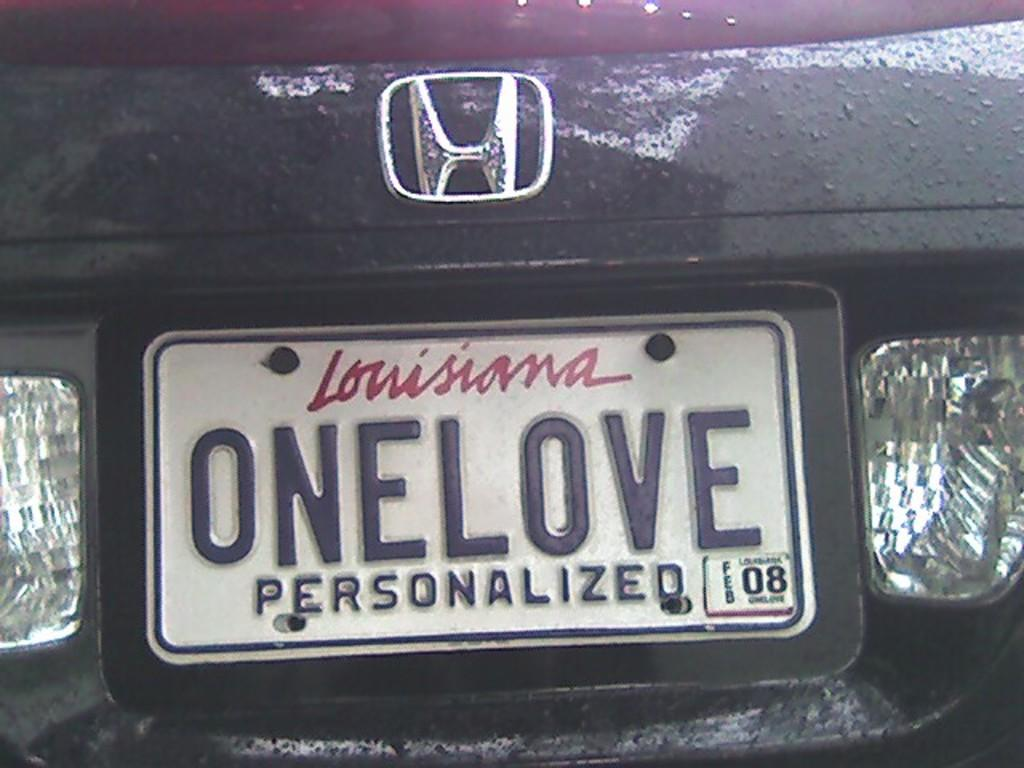Provide a one-sentence caption for the provided image. A customized license plate is on a Honda car with the word ONELOVE. 